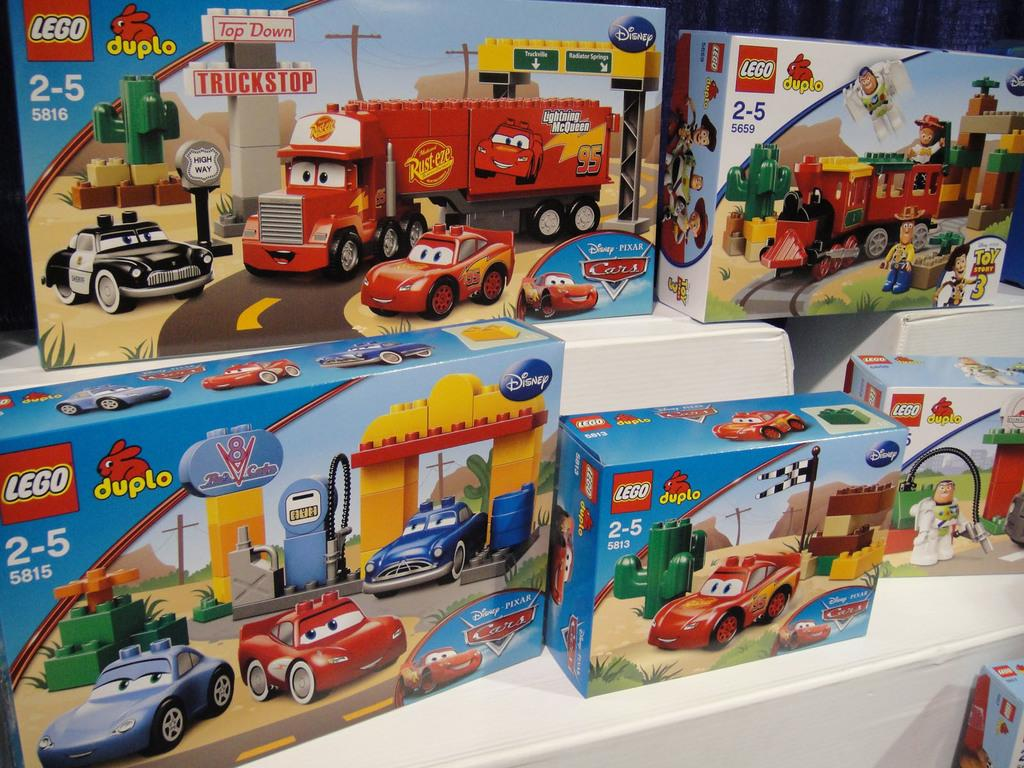What type of objects are visible in the image? There are toy vehicle boxes in the image. Where are the toy vehicle boxes located? The toy vehicle boxes are placed on a white surface. What type of division is being taught using the toy vehicle boxes in the image? There is no indication of any division or teaching activity in the image; it simply shows toy vehicle boxes placed on a white surface. 